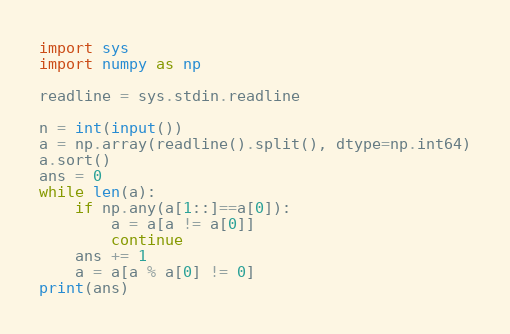Convert code to text. <code><loc_0><loc_0><loc_500><loc_500><_Python_>import sys
import numpy as np

readline = sys.stdin.readline

n = int(input())
a = np.array(readline().split(), dtype=np.int64)
a.sort()
ans = 0
while len(a):
    if np.any(a[1::]==a[0]):
        a = a[a != a[0]]
        continue
    ans += 1
    a = a[a % a[0] != 0]
print(ans)</code> 